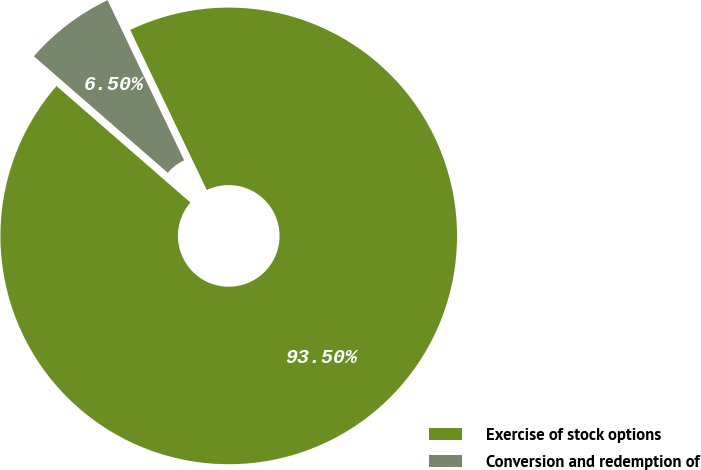Convert chart to OTSL. <chart><loc_0><loc_0><loc_500><loc_500><pie_chart><fcel>Exercise of stock options<fcel>Conversion and redemption of<nl><fcel>93.5%<fcel>6.5%<nl></chart> 